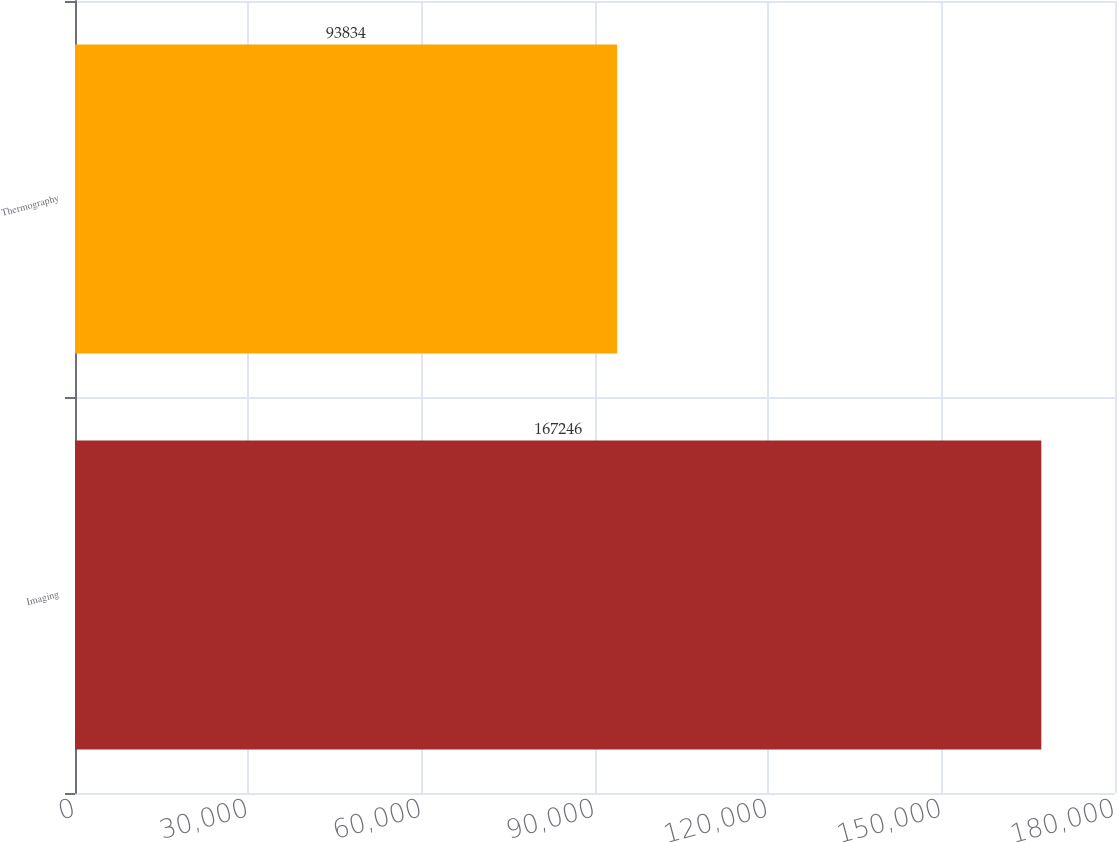Convert chart. <chart><loc_0><loc_0><loc_500><loc_500><bar_chart><fcel>Imaging<fcel>Thermography<nl><fcel>167246<fcel>93834<nl></chart> 